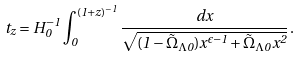Convert formula to latex. <formula><loc_0><loc_0><loc_500><loc_500>t _ { z } = H ^ { - 1 } _ { 0 } \int _ { 0 } ^ { ( 1 + z ) ^ { - 1 } } \frac { d x } { \sqrt { ( 1 - { \tilde { \Omega } } _ { \Lambda 0 } ) x ^ { \epsilon - 1 } + { \tilde { \Omega } } _ { \Lambda 0 } x ^ { 2 } } } \, .</formula> 